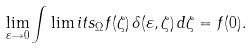Convert formula to latex. <formula><loc_0><loc_0><loc_500><loc_500>\lim _ { \varepsilon \rightarrow 0 } \int \lim i t s _ { \Omega } f ( \zeta ) \, \delta ( \varepsilon , \zeta ) \, d \zeta = f ( 0 ) .</formula> 